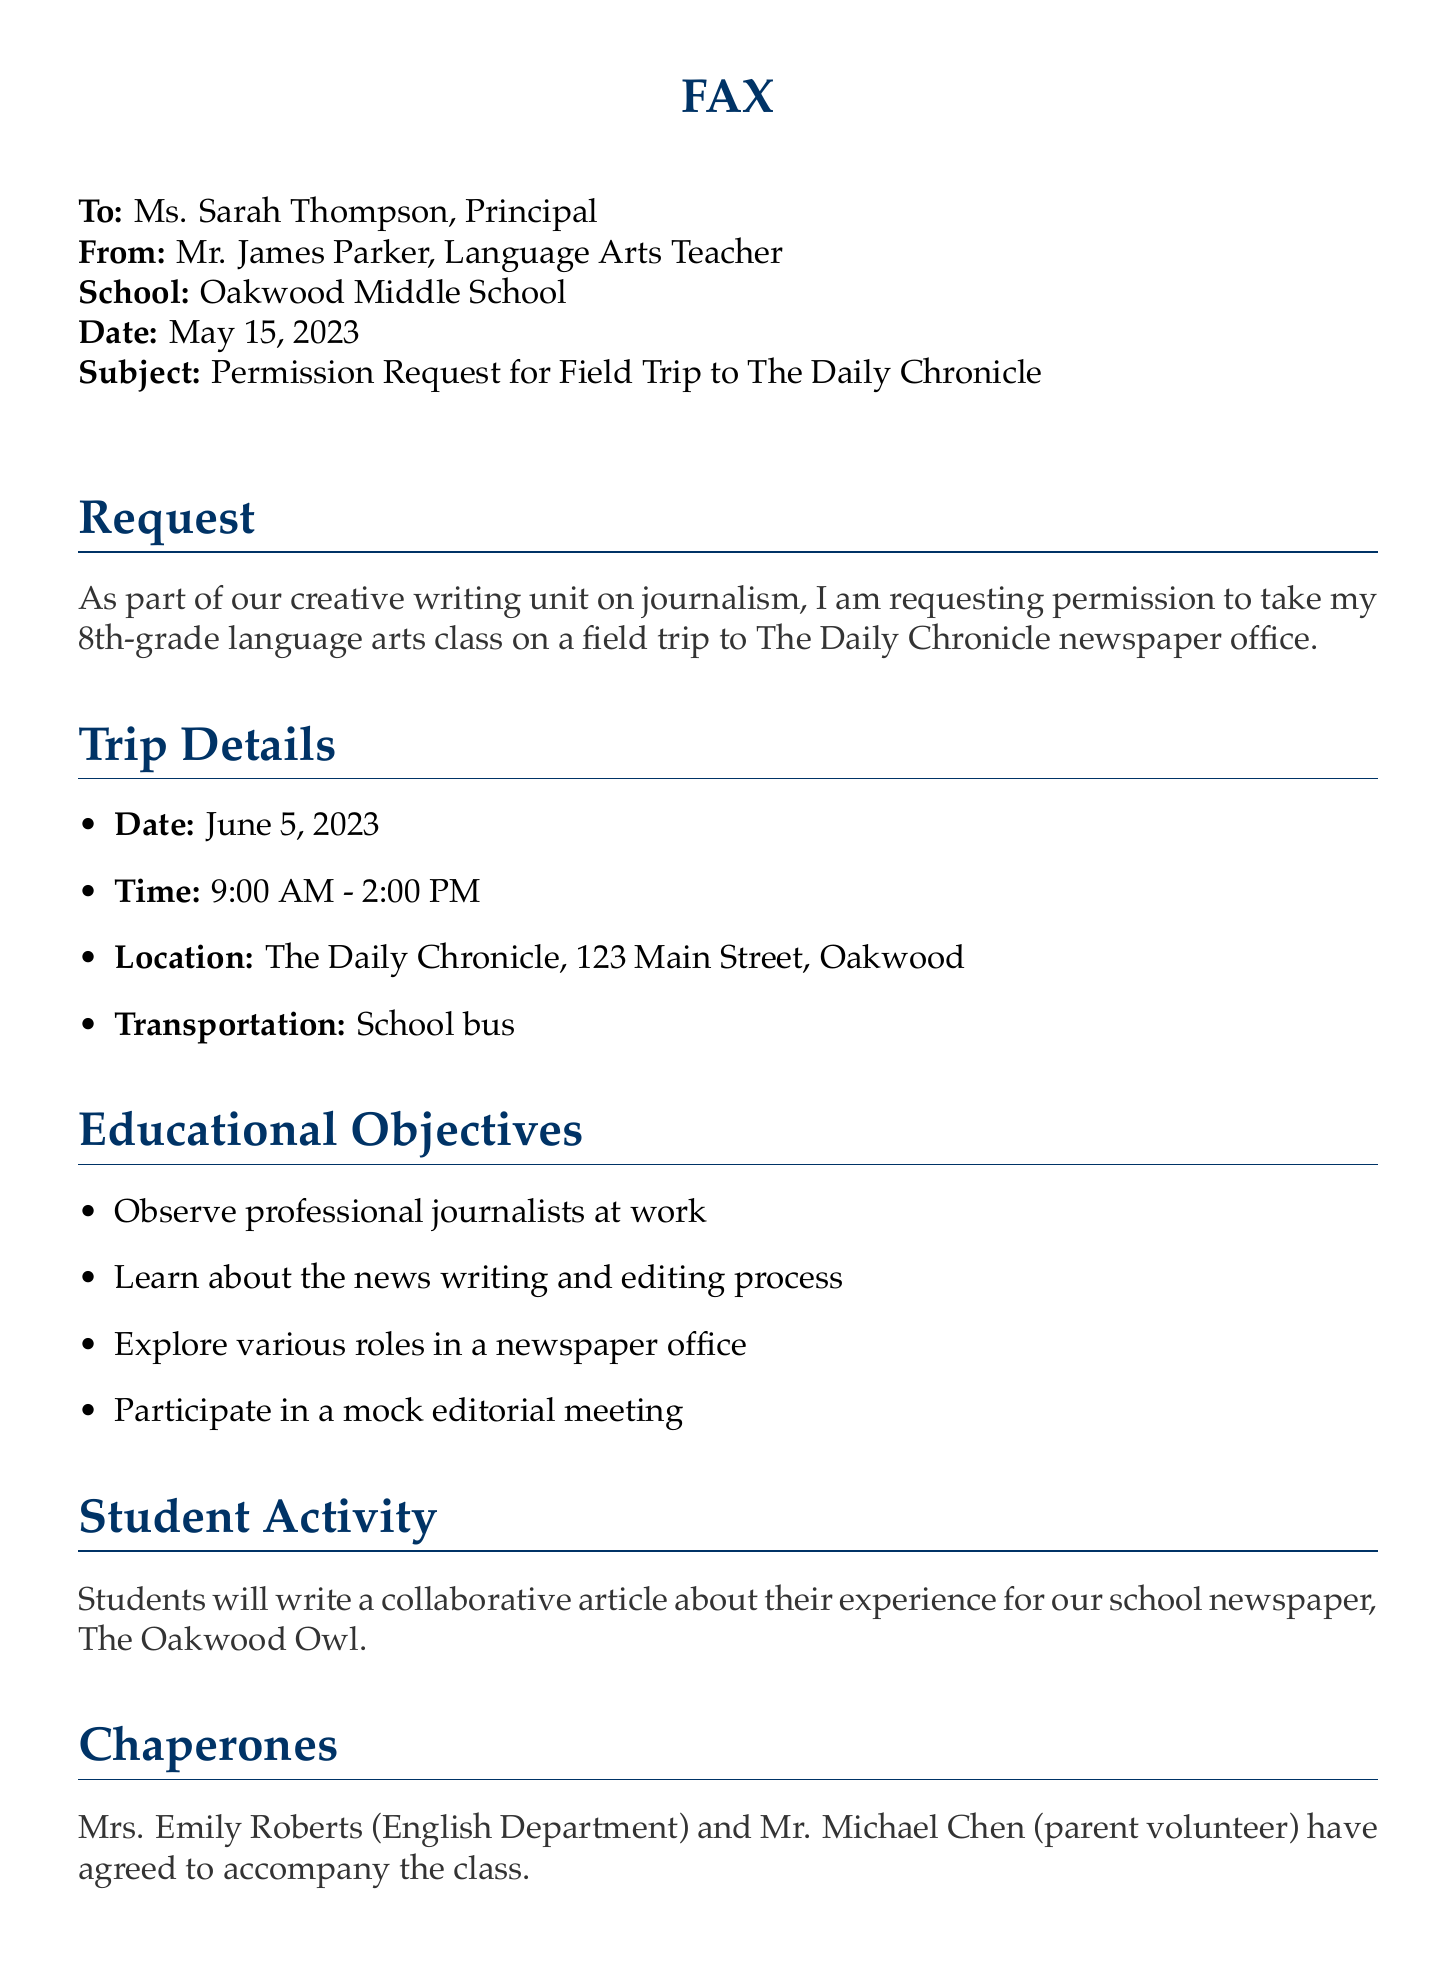what is the name of the school? The document states the name of the school is Oakwood Middle School.
Answer: Oakwood Middle School who is the recipient of the fax? According to the document, the fax is addressed to Ms. Sarah Thompson, the Principal.
Answer: Ms. Sarah Thompson what is the date of the field trip? The document specifies that the field trip is scheduled for June 5, 2023.
Answer: June 5, 2023 who will accompany the class? The document lists Mrs. Emily Roberts and Mr. Michael Chen as chaperones.
Answer: Mrs. Emily Roberts and Mr. Michael Chen what is the main educational objective of the trip? The document outlines that one objective is to observe professional journalists at work.
Answer: Observe professional journalists at work how long will the field trip last? The time indicated for the field trip is from 9:00 AM to 2:00 PM, which is 5 hours.
Answer: 5 hours is there a cost associated with the field trip? The document mentions that the field trip is free of charge.
Answer: Free of charge what is the name of the school newspaper? According to the document, the school newspaper is called The Oakwood Owl.
Answer: The Oakwood Owl what type of meeting will students participate in? The document states that students will participate in a mock editorial meeting.
Answer: Mock editorial meeting 